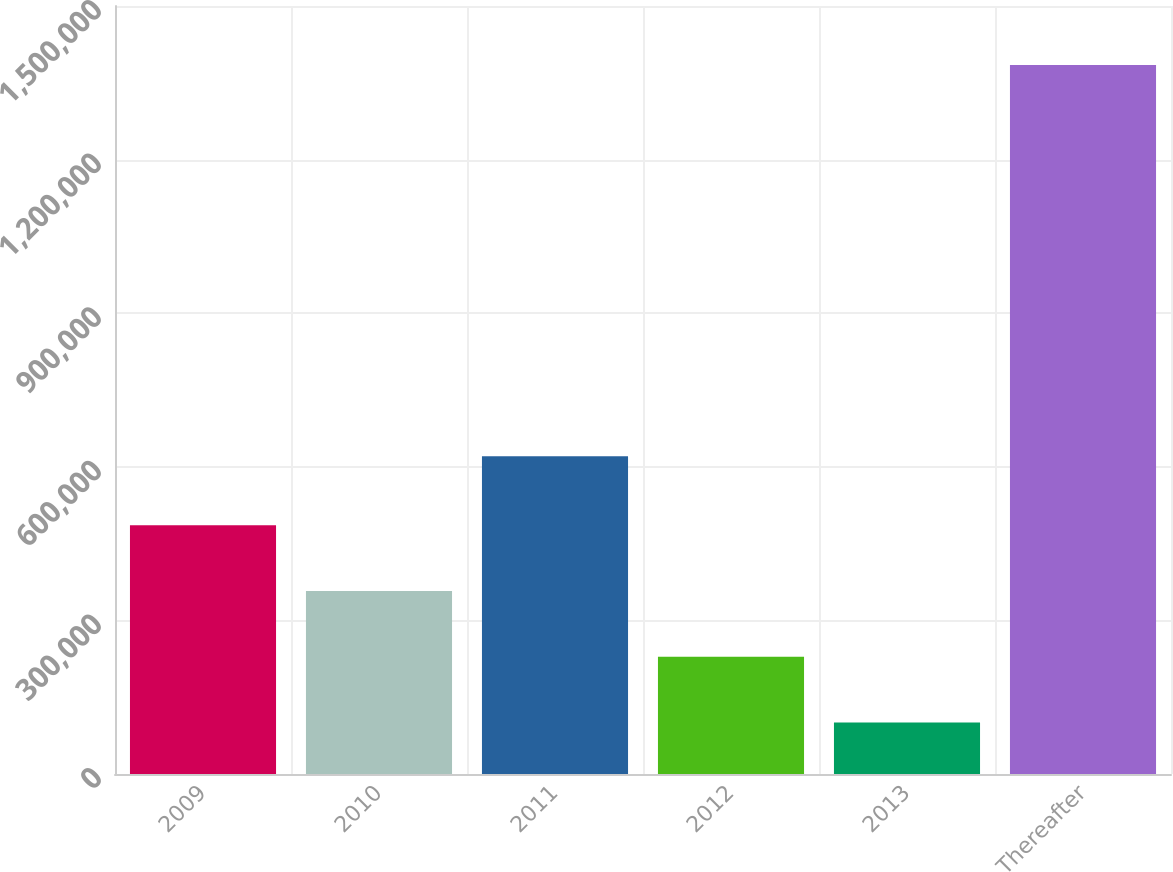Convert chart. <chart><loc_0><loc_0><loc_500><loc_500><bar_chart><fcel>2009<fcel>2010<fcel>2011<fcel>2012<fcel>2013<fcel>Thereafter<nl><fcel>485792<fcel>357340<fcel>620808<fcel>228888<fcel>100436<fcel>1.38496e+06<nl></chart> 